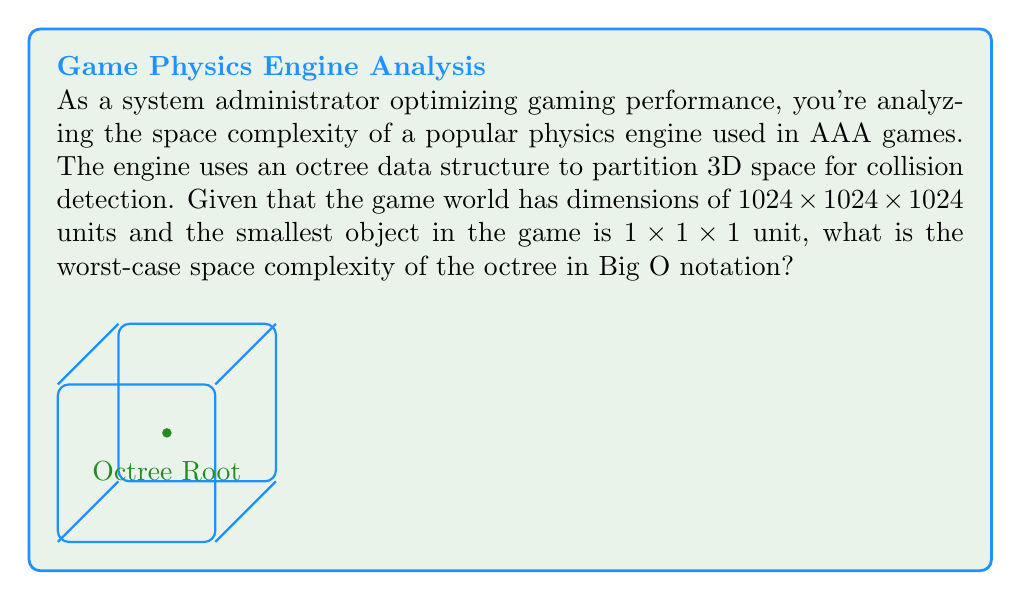Give your solution to this math problem. To determine the space complexity of the octree, we need to follow these steps:

1) First, let's calculate the maximum depth of the octree:
   - The game world is $1024 \times 1024 \times 1024$ units
   - The smallest object is $1 \times 1 \times 1$ unit
   - At each level, the octree divides space into 8 equal parts
   - So, we need to find $n$ where $1024 = 2^n$
   - $2^{10} = 1024$, so the maximum depth is 10 levels

2) In the worst case, every leaf node in the octree will contain an object:
   - At the deepest level, there are $8^{10}$ leaf nodes
   - $8^{10} = (2^3)^{10} = 2^{30} \approx 1.07 \times 10^9$ nodes

3) Each node in the octree typically stores:
   - 8 pointers to child nodes (or NULL if it's a leaf)
   - Coordinates of its bounding box
   - A list of objects it contains (for leaf nodes)

4) The space required for each node is constant, let's call it $c$

5) Therefore, the total space required in the worst case is:
   $S = c \times 2^{30}$

6) In Big O notation, we express this as $O(2^{30})$ or more generally, $O(8^d)$ where $d$ is the depth of the tree

7) Since the depth $d$ is logarithmic with respect to the world size $n$ ($d = \log_2 n$), we can also express this as $O(n^3)$, where $n$ is the side length of the cubic world

Therefore, the worst-case space complexity of the octree is $O(n^3)$, where $n$ is the side length of the game world.
Answer: $O(n^3)$ 